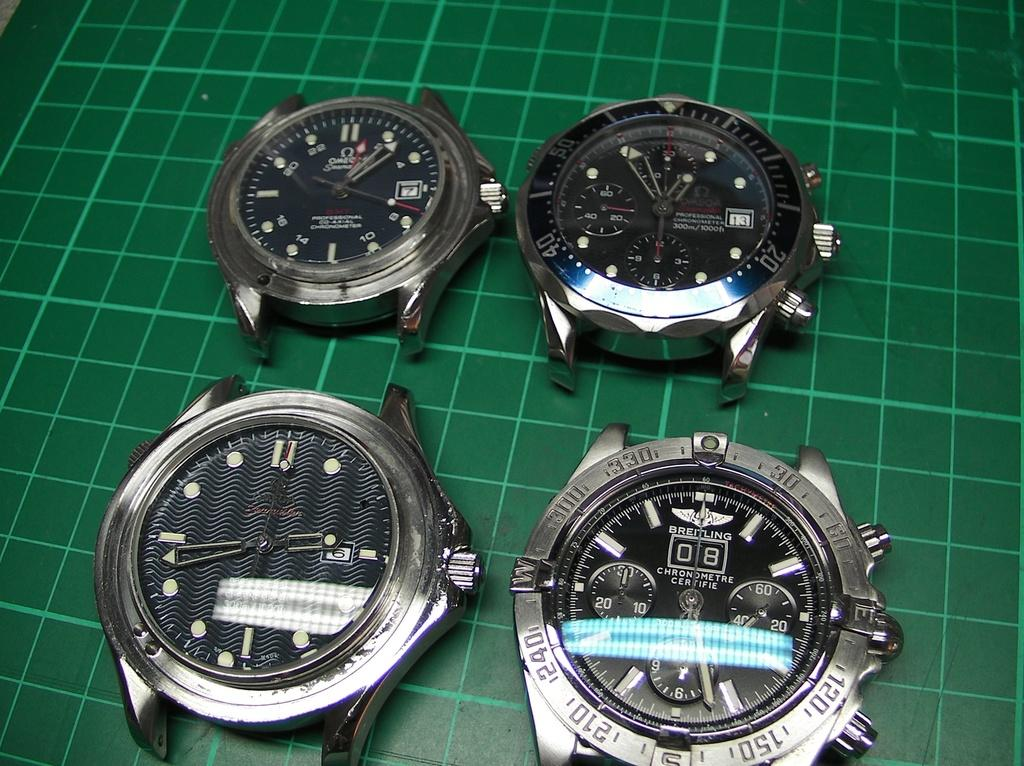<image>
Describe the image concisely. Watches next to one another with one that says BREITLING on it. 